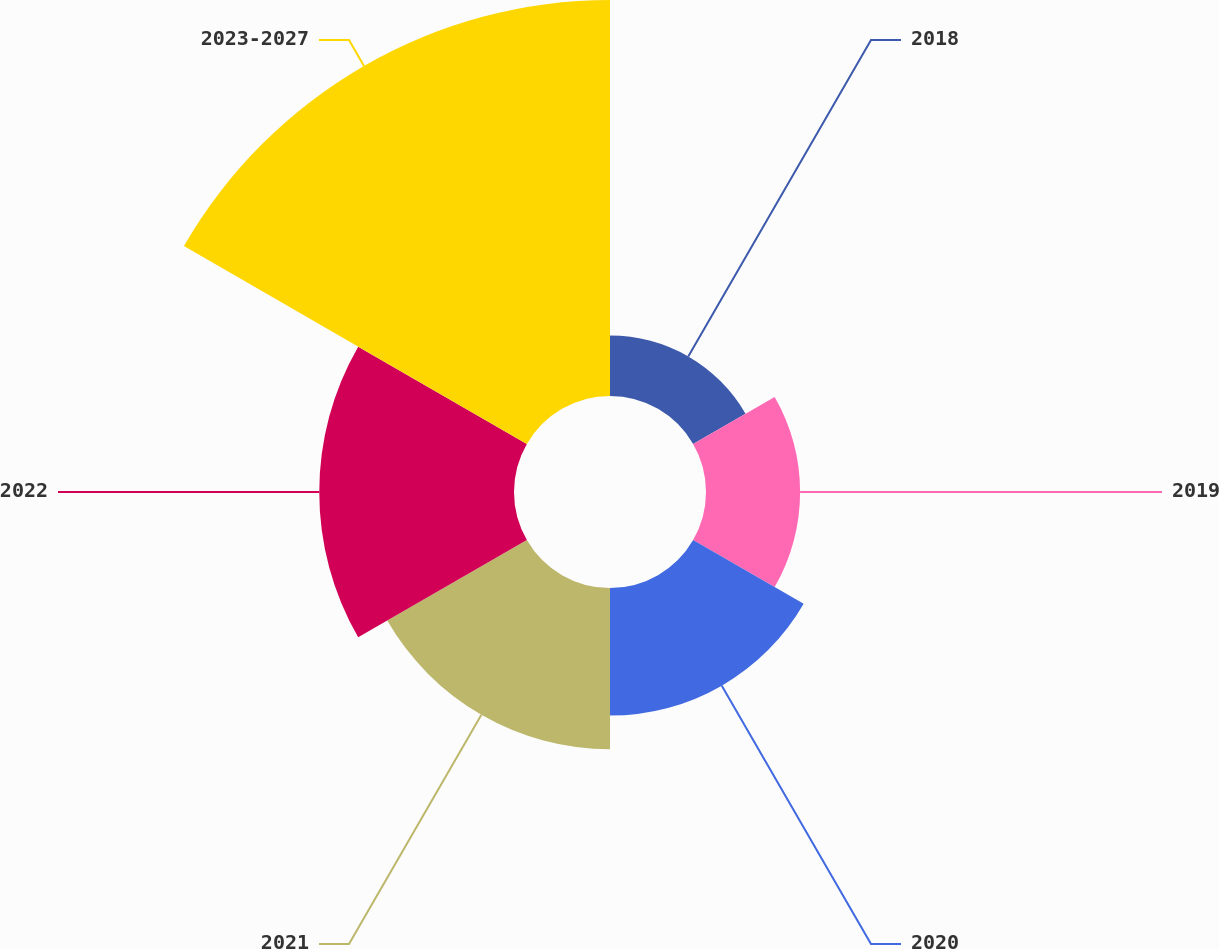<chart> <loc_0><loc_0><loc_500><loc_500><pie_chart><fcel>2018<fcel>2019<fcel>2020<fcel>2021<fcel>2022<fcel>2023-2027<nl><fcel>5.85%<fcel>9.1%<fcel>12.34%<fcel>15.59%<fcel>18.83%<fcel>38.29%<nl></chart> 